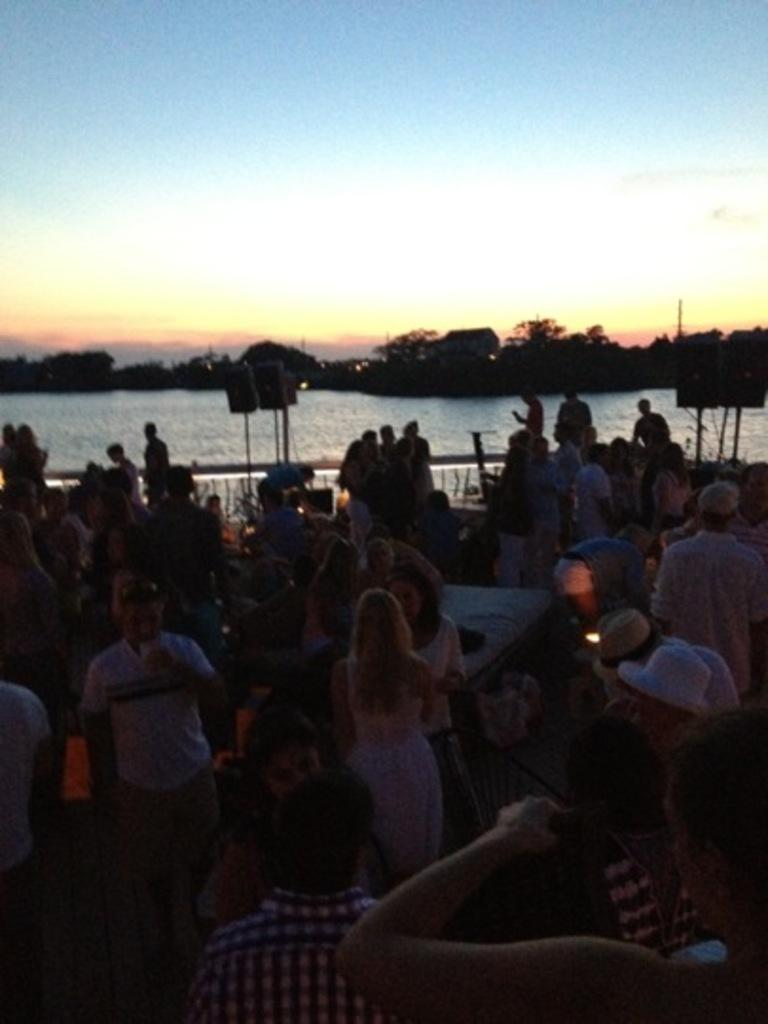How many people are in the image? There are people in the image, but the exact number is not specified. What are the people doing in the image? The people are doing different activities in the image. What can be seen in the background of the image? There is a river, trees, and the sky visible in the background of the image. Can you tell me how many wires are supporting the people in the image? There are no wires supporting the people in the image; they are doing different activities without any visible support. What type of laughter can be heard coming from the people in the image? There is no indication of any laughter in the image, as it only shows people doing different activities. 